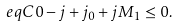<formula> <loc_0><loc_0><loc_500><loc_500>\ e q { C 0 } - j + j _ { 0 } + j M _ { 1 } \leq 0 .</formula> 